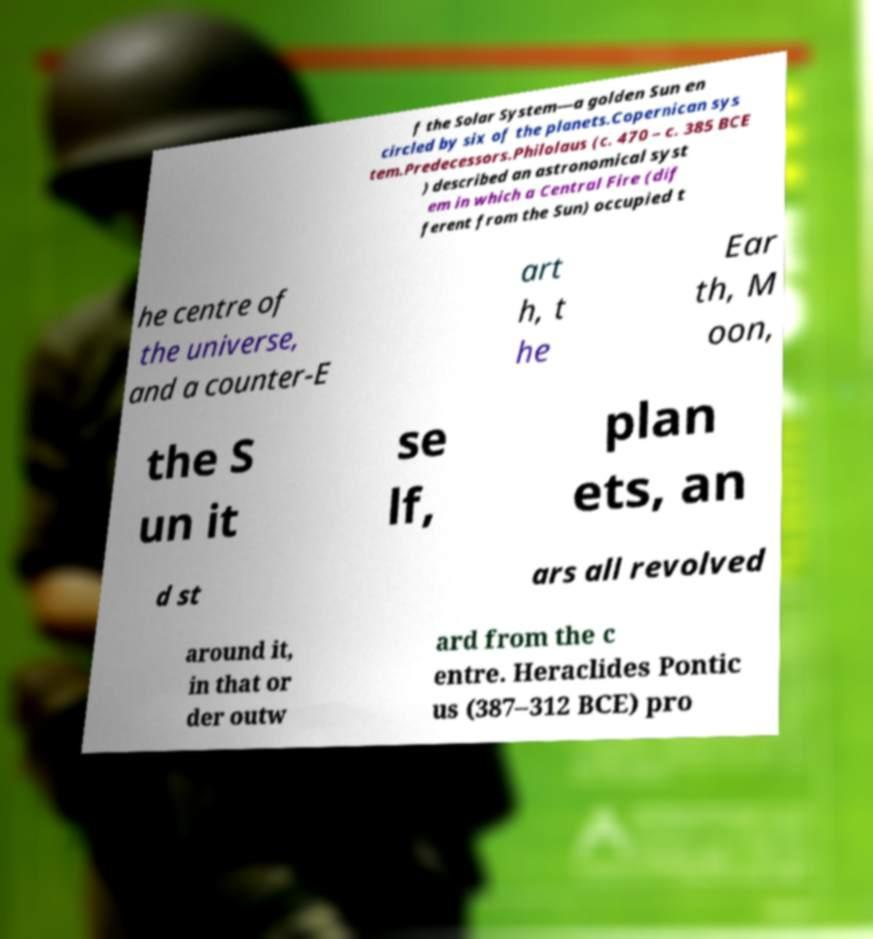I need the written content from this picture converted into text. Can you do that? f the Solar System—a golden Sun en circled by six of the planets.Copernican sys tem.Predecessors.Philolaus (c. 470 – c. 385 BCE ) described an astronomical syst em in which a Central Fire (dif ferent from the Sun) occupied t he centre of the universe, and a counter-E art h, t he Ear th, M oon, the S un it se lf, plan ets, an d st ars all revolved around it, in that or der outw ard from the c entre. Heraclides Pontic us (387–312 BCE) pro 